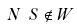Convert formula to latex. <formula><loc_0><loc_0><loc_500><loc_500>N \ S \notin W</formula> 